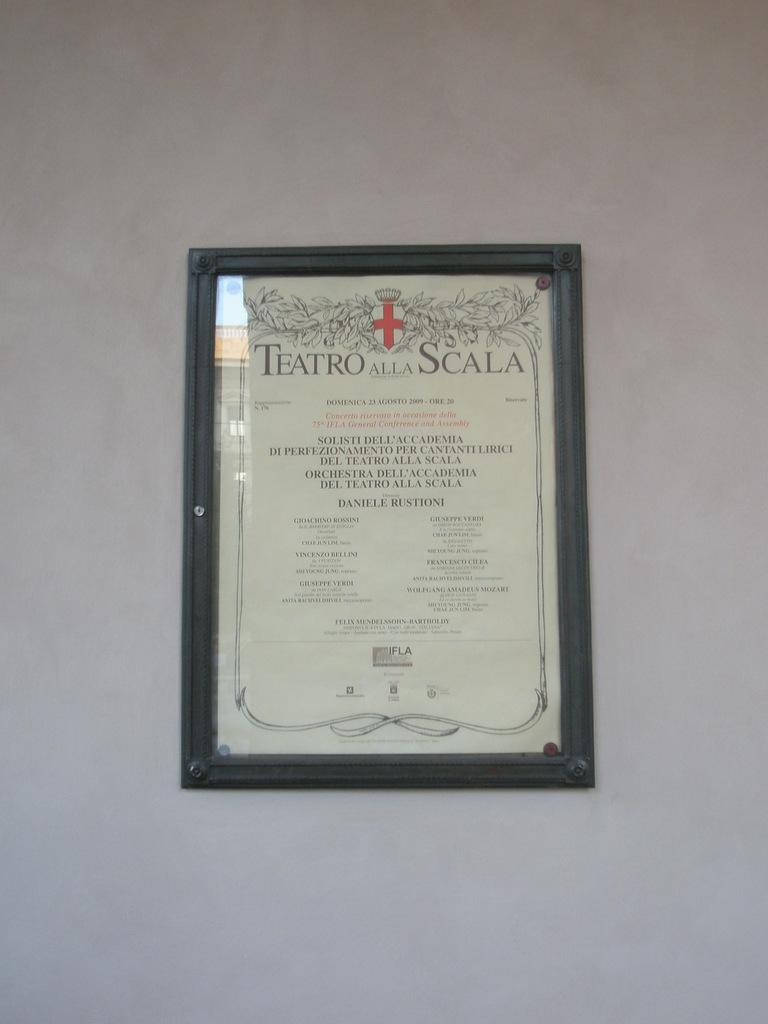<image>
Render a clear and concise summary of the photo. A framed document hanging on the wall is titled "Teatro Alla Scala". 